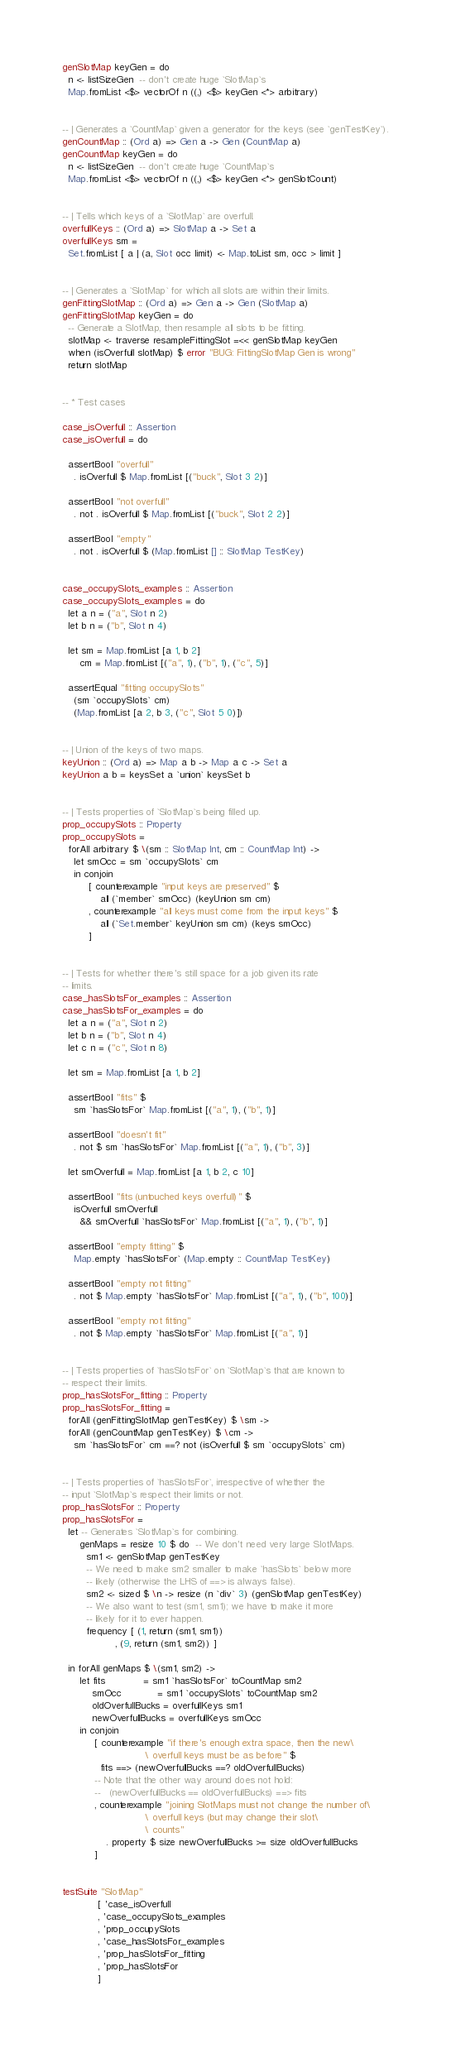<code> <loc_0><loc_0><loc_500><loc_500><_Haskell_>genSlotMap keyGen = do
  n <- listSizeGen  -- don't create huge `SlotMap`s
  Map.fromList <$> vectorOf n ((,) <$> keyGen <*> arbitrary)


-- | Generates a `CountMap` given a generator for the keys (see `genTestKey`).
genCountMap :: (Ord a) => Gen a -> Gen (CountMap a)
genCountMap keyGen = do
  n <- listSizeGen  -- don't create huge `CountMap`s
  Map.fromList <$> vectorOf n ((,) <$> keyGen <*> genSlotCount)


-- | Tells which keys of a `SlotMap` are overfull.
overfullKeys :: (Ord a) => SlotMap a -> Set a
overfullKeys sm =
  Set.fromList [ a | (a, Slot occ limit) <- Map.toList sm, occ > limit ]


-- | Generates a `SlotMap` for which all slots are within their limits.
genFittingSlotMap :: (Ord a) => Gen a -> Gen (SlotMap a)
genFittingSlotMap keyGen = do
  -- Generate a SlotMap, then resample all slots to be fitting.
  slotMap <- traverse resampleFittingSlot =<< genSlotMap keyGen
  when (isOverfull slotMap) $ error "BUG: FittingSlotMap Gen is wrong"
  return slotMap


-- * Test cases

case_isOverfull :: Assertion
case_isOverfull = do

  assertBool "overfull"
    . isOverfull $ Map.fromList [("buck", Slot 3 2)]

  assertBool "not overfull"
    . not . isOverfull $ Map.fromList [("buck", Slot 2 2)]

  assertBool "empty"
    . not . isOverfull $ (Map.fromList [] :: SlotMap TestKey)


case_occupySlots_examples :: Assertion
case_occupySlots_examples = do
  let a n = ("a", Slot n 2)
  let b n = ("b", Slot n 4)

  let sm = Map.fromList [a 1, b 2]
      cm = Map.fromList [("a", 1), ("b", 1), ("c", 5)]

  assertEqual "fitting occupySlots"
    (sm `occupySlots` cm)
    (Map.fromList [a 2, b 3, ("c", Slot 5 0)])


-- | Union of the keys of two maps.
keyUnion :: (Ord a) => Map a b -> Map a c -> Set a
keyUnion a b = keysSet a `union` keysSet b


-- | Tests properties of `SlotMap`s being filled up.
prop_occupySlots :: Property
prop_occupySlots =
  forAll arbitrary $ \(sm :: SlotMap Int, cm :: CountMap Int) ->
    let smOcc = sm `occupySlots` cm
    in conjoin
         [ counterexample "input keys are preserved" $
             all (`member` smOcc) (keyUnion sm cm)
         , counterexample "all keys must come from the input keys" $
             all (`Set.member` keyUnion sm cm) (keys smOcc)
         ]


-- | Tests for whether there's still space for a job given its rate
-- limits.
case_hasSlotsFor_examples :: Assertion
case_hasSlotsFor_examples = do
  let a n = ("a", Slot n 2)
  let b n = ("b", Slot n 4)
  let c n = ("c", Slot n 8)

  let sm = Map.fromList [a 1, b 2]

  assertBool "fits" $
    sm `hasSlotsFor` Map.fromList [("a", 1), ("b", 1)]

  assertBool "doesn't fit"
    . not $ sm `hasSlotsFor` Map.fromList [("a", 1), ("b", 3)]

  let smOverfull = Map.fromList [a 1, b 2, c 10]

  assertBool "fits (untouched keys overfull)" $
    isOverfull smOverfull
      && smOverfull `hasSlotsFor` Map.fromList [("a", 1), ("b", 1)]

  assertBool "empty fitting" $
    Map.empty `hasSlotsFor` (Map.empty :: CountMap TestKey)

  assertBool "empty not fitting"
    . not $ Map.empty `hasSlotsFor` Map.fromList [("a", 1), ("b", 100)]

  assertBool "empty not fitting"
    . not $ Map.empty `hasSlotsFor` Map.fromList [("a", 1)]


-- | Tests properties of `hasSlotsFor` on `SlotMap`s that are known to
-- respect their limits.
prop_hasSlotsFor_fitting :: Property
prop_hasSlotsFor_fitting =
  forAll (genFittingSlotMap genTestKey) $ \sm ->
  forAll (genCountMap genTestKey) $ \cm ->
    sm `hasSlotsFor` cm ==? not (isOverfull $ sm `occupySlots` cm)


-- | Tests properties of `hasSlotsFor`, irrespective of whether the
-- input `SlotMap`s respect their limits or not.
prop_hasSlotsFor :: Property
prop_hasSlotsFor =
  let -- Generates `SlotMap`s for combining.
      genMaps = resize 10 $ do  -- We don't need very large SlotMaps.
        sm1 <- genSlotMap genTestKey
        -- We need to make sm2 smaller to make `hasSlots` below more
        -- likely (otherwise the LHS of ==> is always false).
        sm2 <- sized $ \n -> resize (n `div` 3) (genSlotMap genTestKey)
        -- We also want to test (sm1, sm1); we have to make it more
        -- likely for it to ever happen.
        frequency [ (1, return (sm1, sm1))
                  , (9, return (sm1, sm2)) ]

  in forAll genMaps $ \(sm1, sm2) ->
      let fits             = sm1 `hasSlotsFor` toCountMap sm2
          smOcc            = sm1 `occupySlots` toCountMap sm2
          oldOverfullBucks = overfullKeys sm1
          newOverfullBucks = overfullKeys smOcc
      in conjoin
           [ counterexample "if there's enough extra space, then the new\
                            \ overfull keys must be as before" $
             fits ==> (newOverfullBucks ==? oldOverfullBucks)
           -- Note that the other way around does not hold:
           --   (newOverfullBucks == oldOverfullBucks) ==> fits
           , counterexample "joining SlotMaps must not change the number of\
                            \ overfull keys (but may change their slot\
                            \ counts"
               . property $ size newOverfullBucks >= size oldOverfullBucks
           ]


testSuite "SlotMap"
            [ 'case_isOverfull
            , 'case_occupySlots_examples
            , 'prop_occupySlots
            , 'case_hasSlotsFor_examples
            , 'prop_hasSlotsFor_fitting
            , 'prop_hasSlotsFor
            ]
</code> 